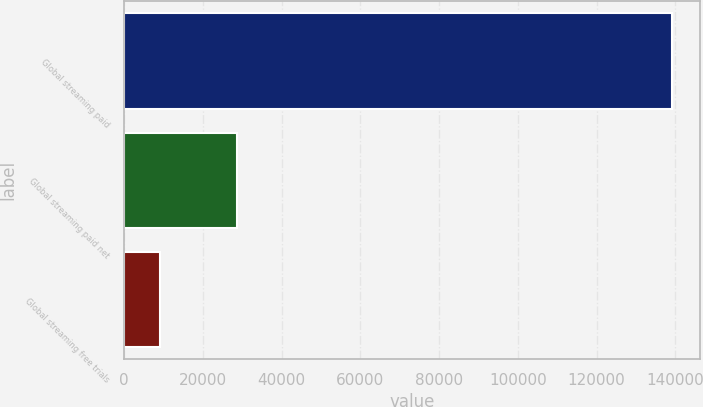<chart> <loc_0><loc_0><loc_500><loc_500><bar_chart><fcel>Global streaming paid<fcel>Global streaming paid net<fcel>Global streaming free trials<nl><fcel>139259<fcel>28615<fcel>9196<nl></chart> 